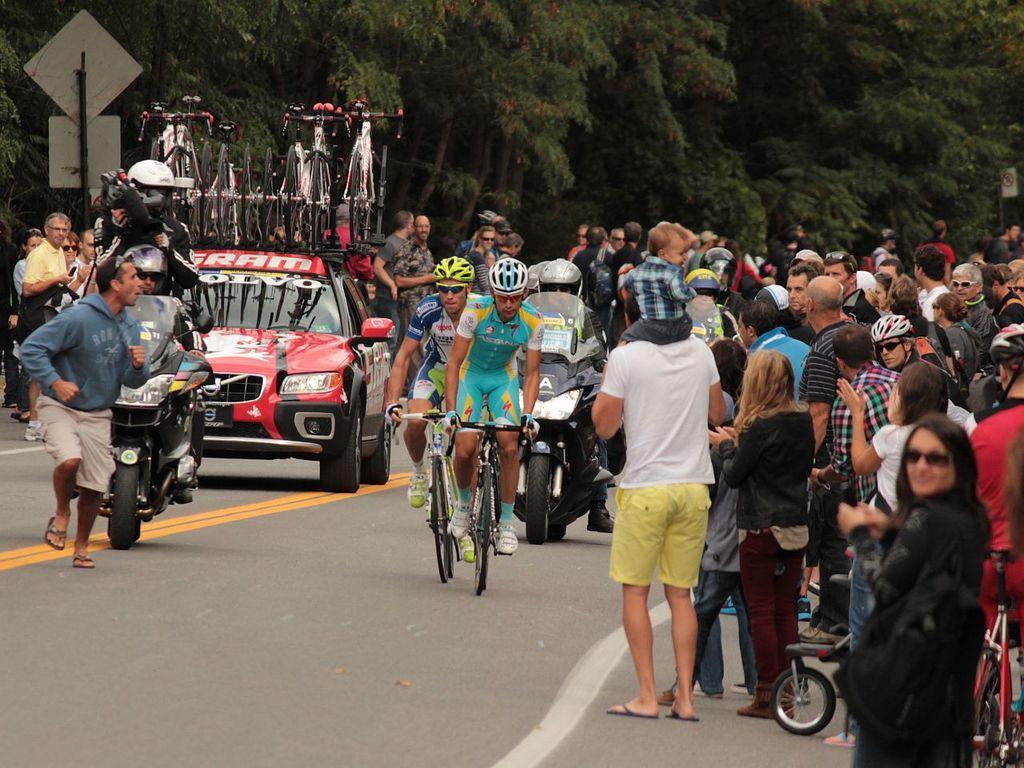In one or two sentences, can you explain what this image depicts? On the background of the picture we can see trees. Here we can all the persons standing on the road. We can see few persons riding vehicles on the road here. this is a red colour car and we can see few bicycles on the car. This is a board. 